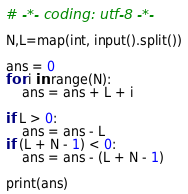<code> <loc_0><loc_0><loc_500><loc_500><_Python_># -*- coding: utf-8 -*-

N,L=map(int, input().split())

ans = 0
for i in range(N):
    ans = ans + L + i

if L > 0:
    ans = ans - L
if (L + N - 1) < 0:
    ans = ans - (L + N - 1)

print(ans)</code> 